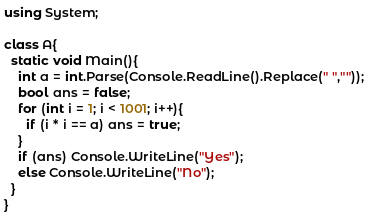Convert code to text. <code><loc_0><loc_0><loc_500><loc_500><_C#_>using System;

class A{
  static void Main(){
    int a = int.Parse(Console.ReadLine().Replace(" ",""));
    bool ans = false;
    for (int i = 1; i < 1001; i++){
      if (i * i == a) ans = true;
    }
    if (ans) Console.WriteLine("Yes");
    else Console.WriteLine("No");
  }
}</code> 